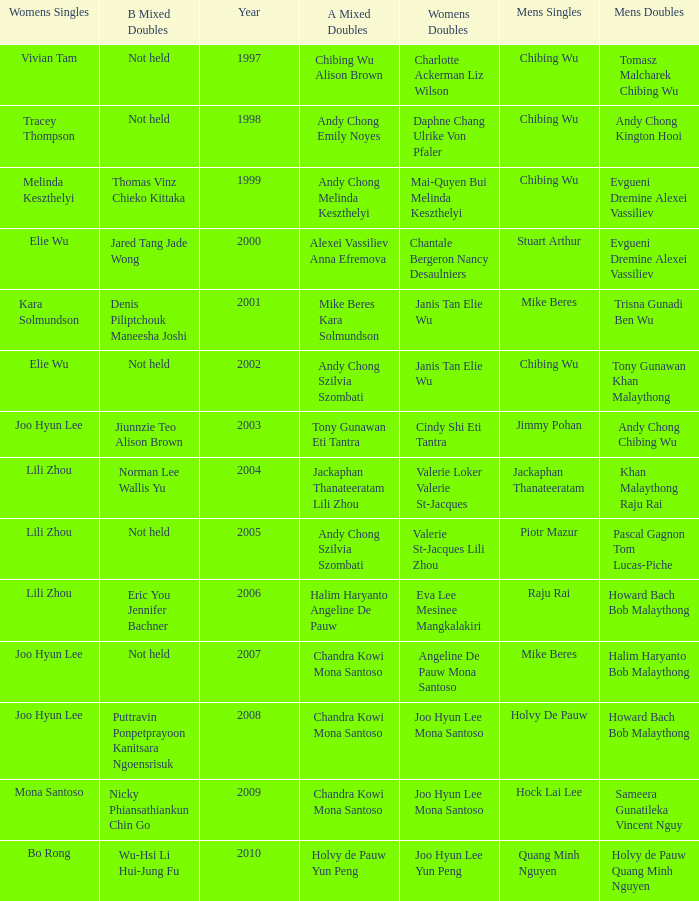Help me parse the entirety of this table. {'header': ['Womens Singles', 'B Mixed Doubles', 'Year', 'A Mixed Doubles', 'Womens Doubles', 'Mens Singles', 'Mens Doubles'], 'rows': [['Vivian Tam', 'Not held', '1997', 'Chibing Wu Alison Brown', 'Charlotte Ackerman Liz Wilson', 'Chibing Wu', 'Tomasz Malcharek Chibing Wu'], ['Tracey Thompson', 'Not held', '1998', 'Andy Chong Emily Noyes', 'Daphne Chang Ulrike Von Pfaler', 'Chibing Wu', 'Andy Chong Kington Hooi'], ['Melinda Keszthelyi', 'Thomas Vinz Chieko Kittaka', '1999', 'Andy Chong Melinda Keszthelyi', 'Mai-Quyen Bui Melinda Keszthelyi', 'Chibing Wu', 'Evgueni Dremine Alexei Vassiliev'], ['Elie Wu', 'Jared Tang Jade Wong', '2000', 'Alexei Vassiliev Anna Efremova', 'Chantale Bergeron Nancy Desaulniers', 'Stuart Arthur', 'Evgueni Dremine Alexei Vassiliev'], ['Kara Solmundson', 'Denis Piliptchouk Maneesha Joshi', '2001', 'Mike Beres Kara Solmundson', 'Janis Tan Elie Wu', 'Mike Beres', 'Trisna Gunadi Ben Wu'], ['Elie Wu', 'Not held', '2002', 'Andy Chong Szilvia Szombati', 'Janis Tan Elie Wu', 'Chibing Wu', 'Tony Gunawan Khan Malaythong'], ['Joo Hyun Lee', 'Jiunnzie Teo Alison Brown', '2003', 'Tony Gunawan Eti Tantra', 'Cindy Shi Eti Tantra', 'Jimmy Pohan', 'Andy Chong Chibing Wu'], ['Lili Zhou', 'Norman Lee Wallis Yu', '2004', 'Jackaphan Thanateeratam Lili Zhou', 'Valerie Loker Valerie St-Jacques', 'Jackaphan Thanateeratam', 'Khan Malaythong Raju Rai'], ['Lili Zhou', 'Not held', '2005', 'Andy Chong Szilvia Szombati', 'Valerie St-Jacques Lili Zhou', 'Piotr Mazur', 'Pascal Gagnon Tom Lucas-Piche'], ['Lili Zhou', 'Eric You Jennifer Bachner', '2006', 'Halim Haryanto Angeline De Pauw', 'Eva Lee Mesinee Mangkalakiri', 'Raju Rai', 'Howard Bach Bob Malaythong'], ['Joo Hyun Lee', 'Not held', '2007', 'Chandra Kowi Mona Santoso', 'Angeline De Pauw Mona Santoso', 'Mike Beres', 'Halim Haryanto Bob Malaythong'], ['Joo Hyun Lee', 'Puttravin Ponpetprayoon Kanitsara Ngoensrisuk', '2008', 'Chandra Kowi Mona Santoso', 'Joo Hyun Lee Mona Santoso', 'Holvy De Pauw', 'Howard Bach Bob Malaythong'], ['Mona Santoso', 'Nicky Phiansathiankun Chin Go', '2009', 'Chandra Kowi Mona Santoso', 'Joo Hyun Lee Mona Santoso', 'Hock Lai Lee', 'Sameera Gunatileka Vincent Nguy'], ['Bo Rong', 'Wu-Hsi Li Hui-Jung Fu', '2010', 'Holvy de Pauw Yun Peng', 'Joo Hyun Lee Yun Peng', 'Quang Minh Nguyen', 'Holvy de Pauw Quang Minh Nguyen']]} What is the least year when men's singles is Raju Rai? 2006.0. 